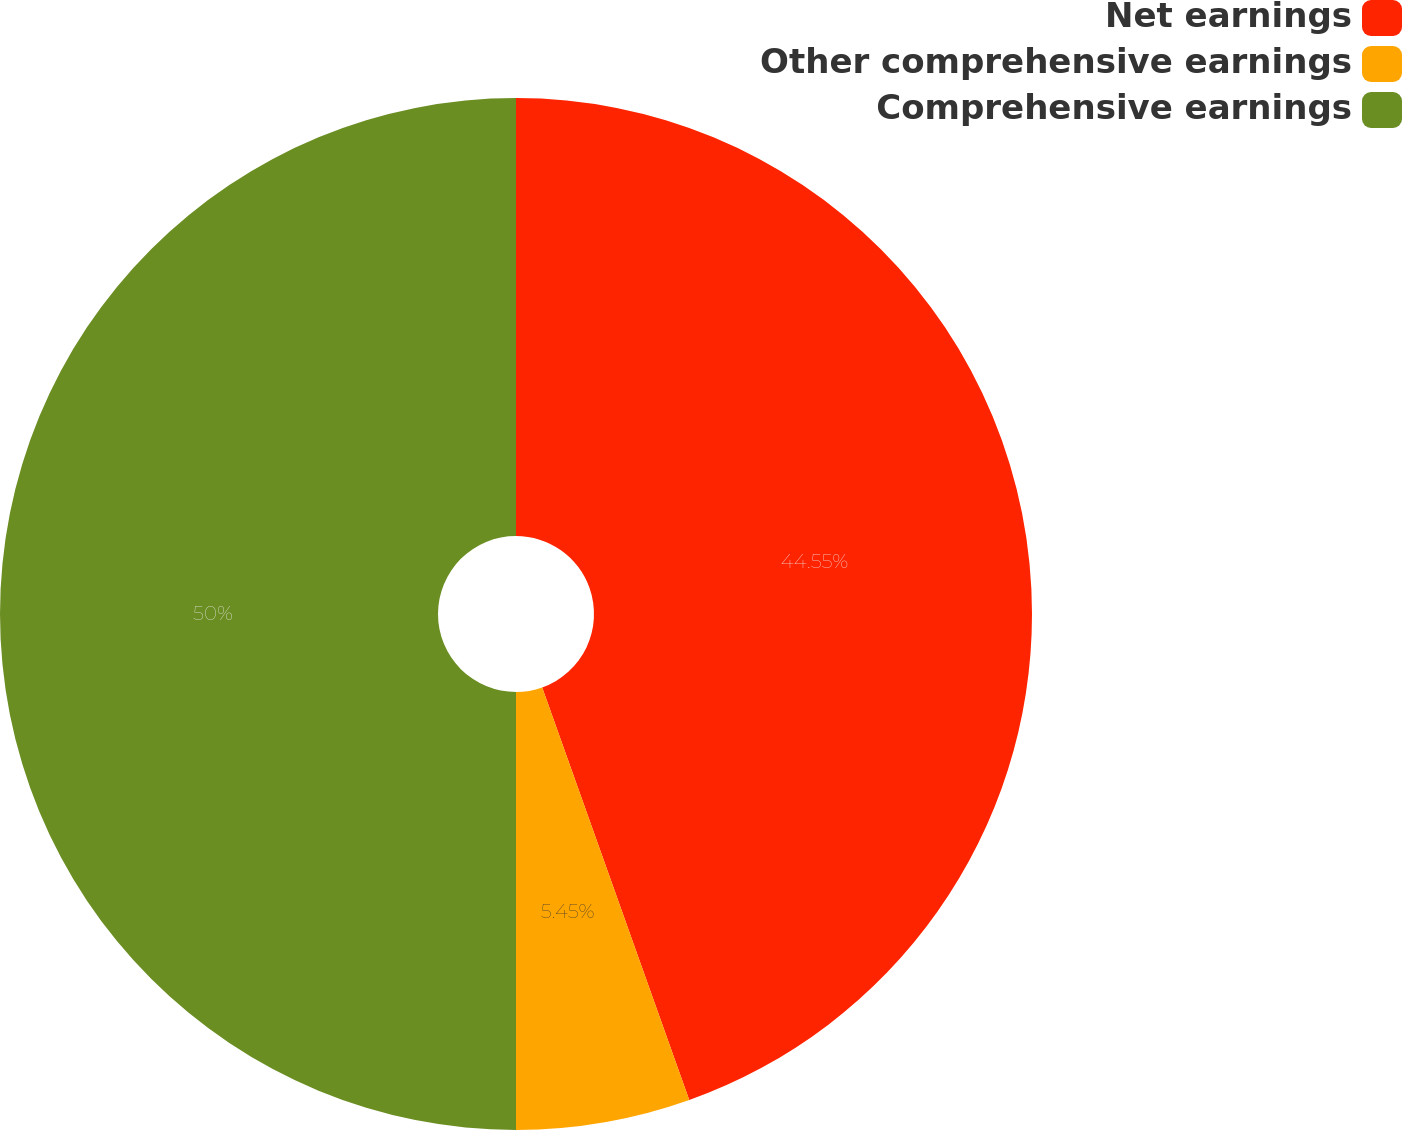Convert chart to OTSL. <chart><loc_0><loc_0><loc_500><loc_500><pie_chart><fcel>Net earnings<fcel>Other comprehensive earnings<fcel>Comprehensive earnings<nl><fcel>44.55%<fcel>5.45%<fcel>50.0%<nl></chart> 